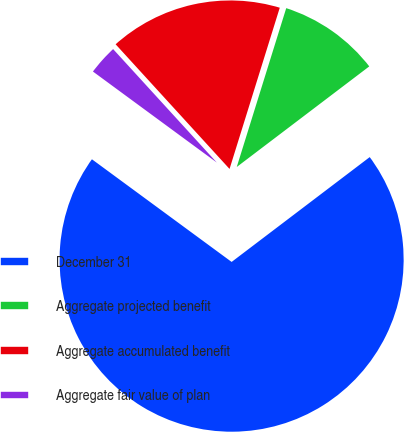Convert chart to OTSL. <chart><loc_0><loc_0><loc_500><loc_500><pie_chart><fcel>December 31<fcel>Aggregate projected benefit<fcel>Aggregate accumulated benefit<fcel>Aggregate fair value of plan<nl><fcel>70.42%<fcel>9.86%<fcel>16.59%<fcel>3.13%<nl></chart> 